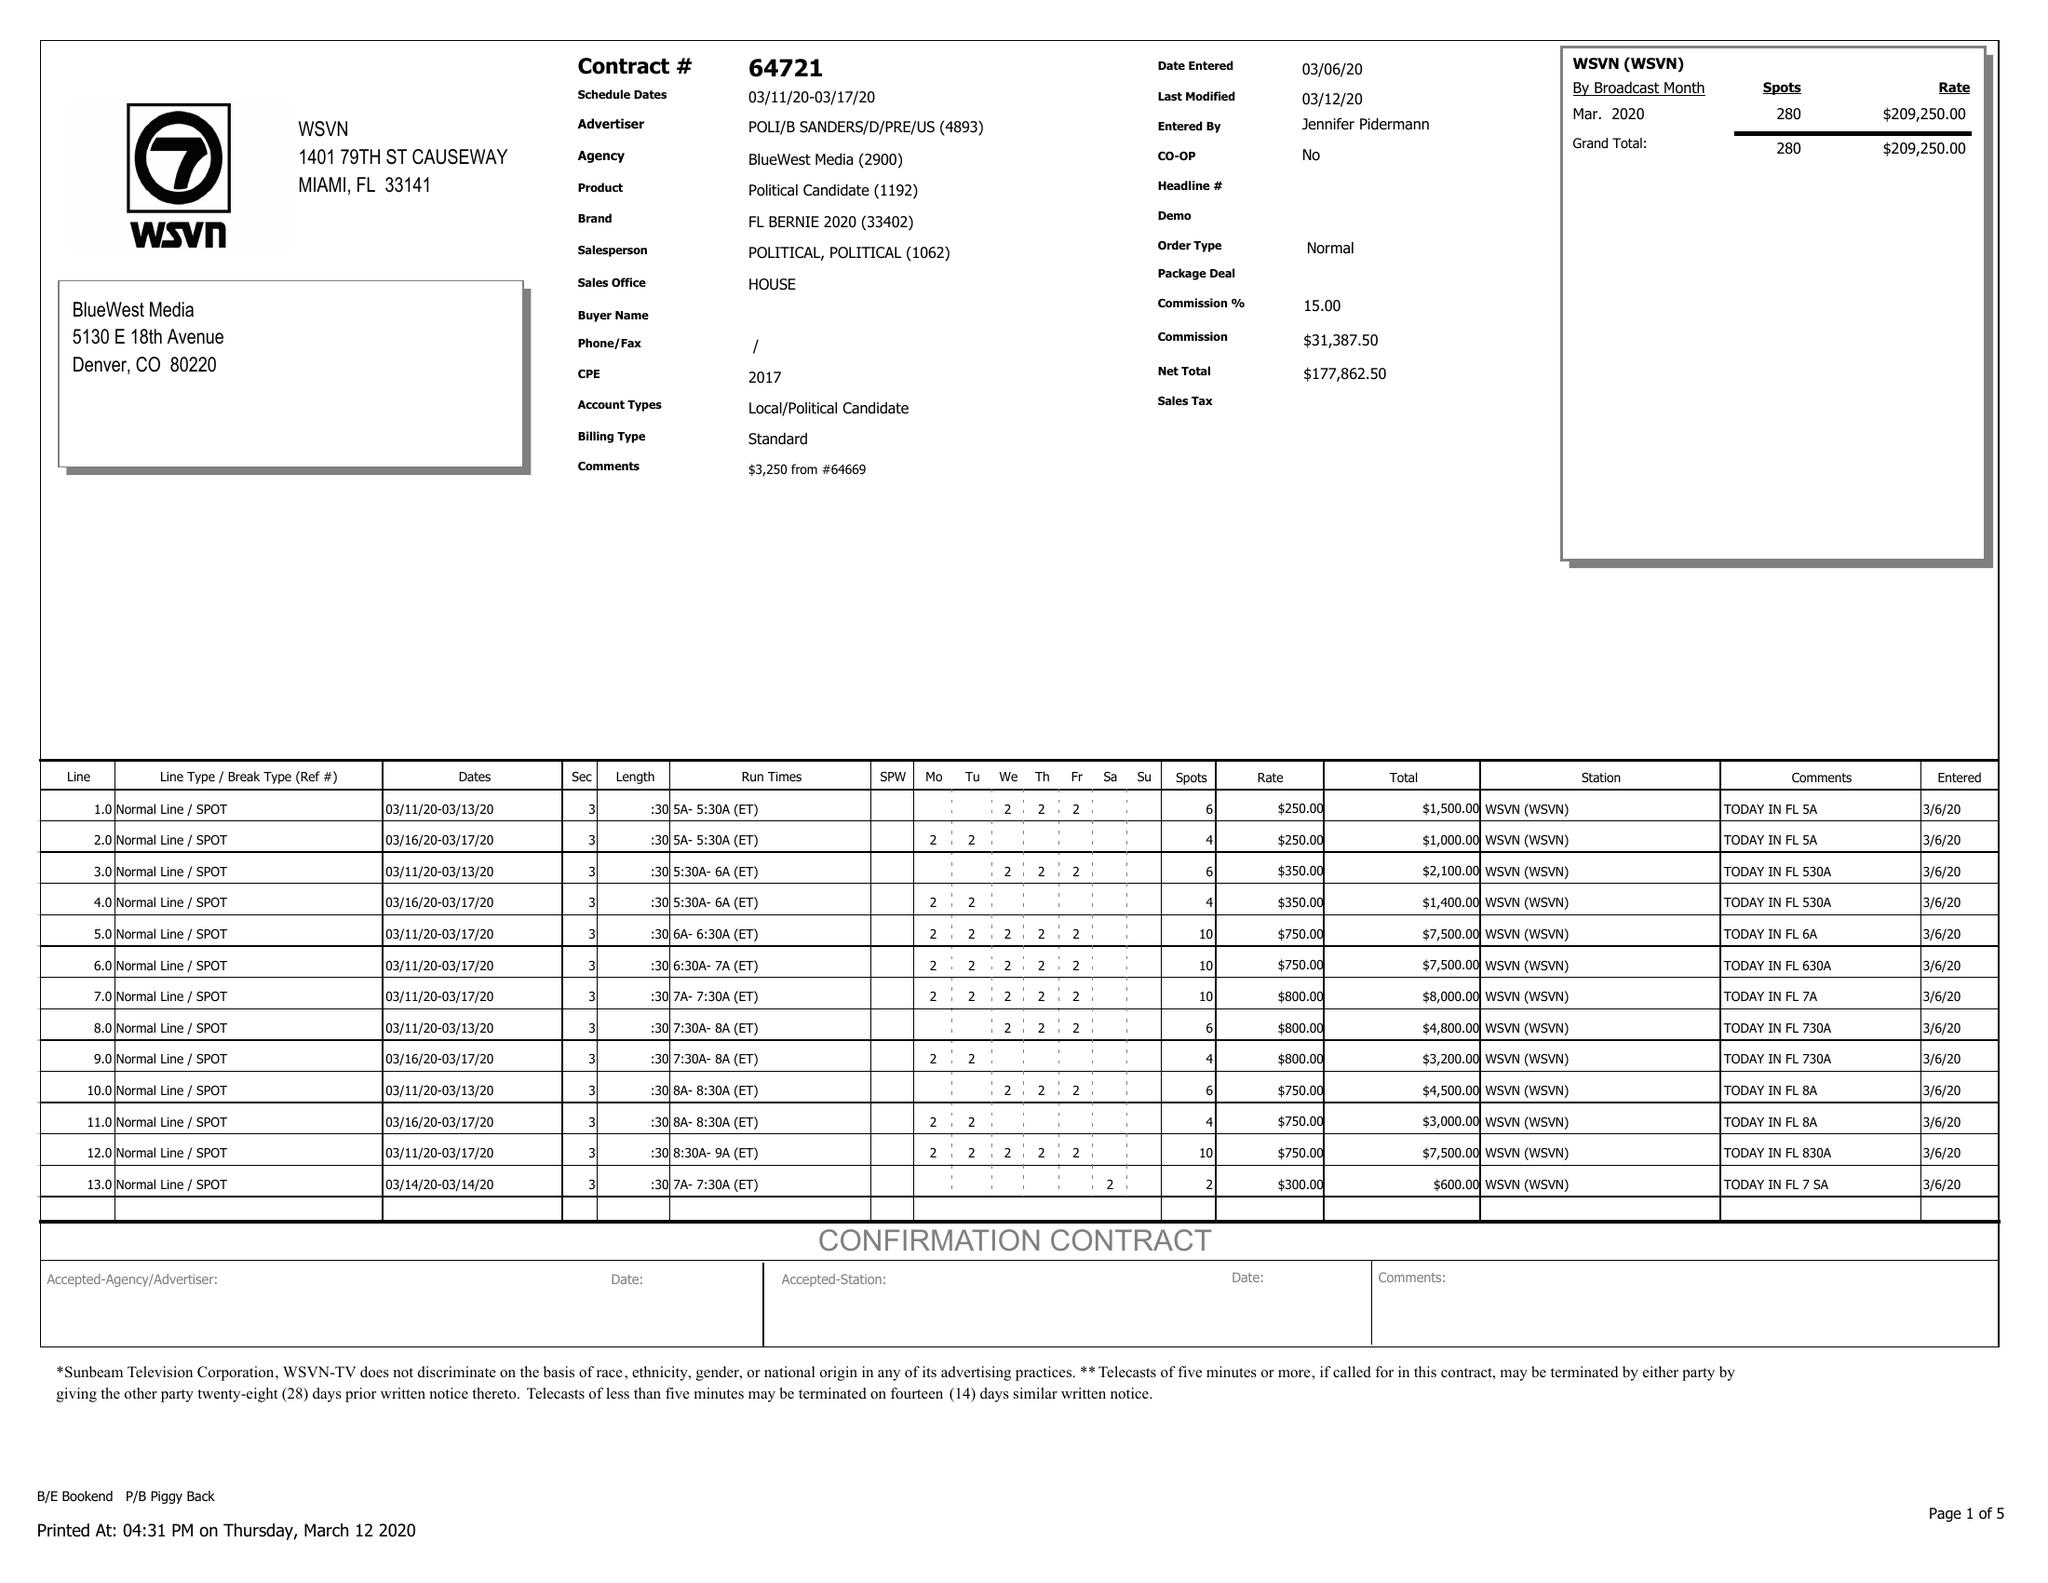What is the value for the flight_to?
Answer the question using a single word or phrase. 03/17/20 